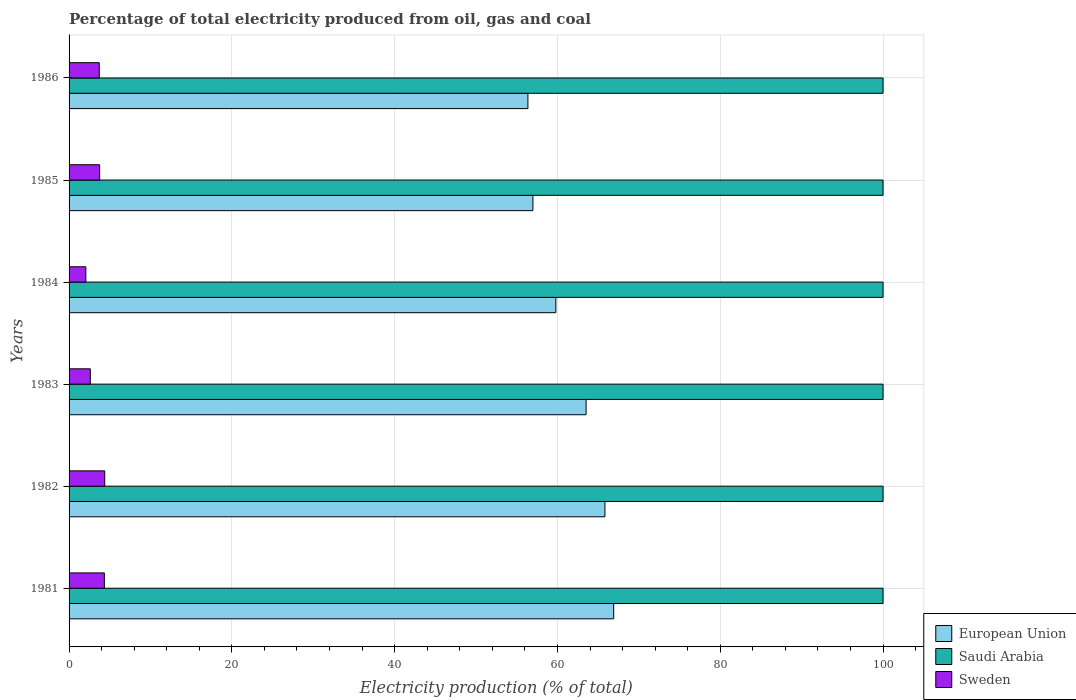How many groups of bars are there?
Provide a succinct answer. 6. Are the number of bars on each tick of the Y-axis equal?
Your answer should be compact. Yes. How many bars are there on the 4th tick from the bottom?
Give a very brief answer. 3. What is the label of the 5th group of bars from the top?
Give a very brief answer. 1982. In how many cases, is the number of bars for a given year not equal to the number of legend labels?
Your answer should be compact. 0. What is the electricity production in in Saudi Arabia in 1986?
Offer a very short reply. 100. Across all years, what is the maximum electricity production in in Saudi Arabia?
Offer a very short reply. 100. What is the total electricity production in in European Union in the graph?
Offer a terse response. 369.41. What is the difference between the electricity production in in Sweden in 1985 and that in 1986?
Ensure brevity in your answer.  0.05. What is the difference between the electricity production in in Sweden in 1982 and the electricity production in in Saudi Arabia in 1984?
Make the answer very short. -95.62. What is the average electricity production in in Sweden per year?
Your response must be concise. 3.48. In the year 1982, what is the difference between the electricity production in in Sweden and electricity production in in European Union?
Your answer should be very brief. -61.45. In how many years, is the electricity production in in Saudi Arabia greater than 40 %?
Your answer should be very brief. 6. What is the ratio of the electricity production in in European Union in 1982 to that in 1984?
Offer a very short reply. 1.1. Is the electricity production in in European Union in 1981 less than that in 1984?
Make the answer very short. No. Is the difference between the electricity production in in Sweden in 1981 and 1986 greater than the difference between the electricity production in in European Union in 1981 and 1986?
Your answer should be compact. No. What is the difference between the highest and the second highest electricity production in in Sweden?
Your response must be concise. 0.04. What is the difference between the highest and the lowest electricity production in in Sweden?
Keep it short and to the point. 2.32. In how many years, is the electricity production in in Saudi Arabia greater than the average electricity production in in Saudi Arabia taken over all years?
Provide a succinct answer. 0. What does the 3rd bar from the bottom in 1986 represents?
Ensure brevity in your answer.  Sweden. Is it the case that in every year, the sum of the electricity production in in Sweden and electricity production in in European Union is greater than the electricity production in in Saudi Arabia?
Offer a terse response. No. How many bars are there?
Your response must be concise. 18. Does the graph contain any zero values?
Make the answer very short. No. Where does the legend appear in the graph?
Keep it short and to the point. Bottom right. What is the title of the graph?
Offer a very short reply. Percentage of total electricity produced from oil, gas and coal. Does "Togo" appear as one of the legend labels in the graph?
Keep it short and to the point. No. What is the label or title of the X-axis?
Your response must be concise. Electricity production (% of total). What is the label or title of the Y-axis?
Make the answer very short. Years. What is the Electricity production (% of total) in European Union in 1981?
Provide a short and direct response. 66.91. What is the Electricity production (% of total) of Sweden in 1981?
Your answer should be compact. 4.34. What is the Electricity production (% of total) of European Union in 1982?
Ensure brevity in your answer.  65.83. What is the Electricity production (% of total) of Sweden in 1982?
Provide a short and direct response. 4.38. What is the Electricity production (% of total) of European Union in 1983?
Keep it short and to the point. 63.52. What is the Electricity production (% of total) in Saudi Arabia in 1983?
Offer a terse response. 100. What is the Electricity production (% of total) in Sweden in 1983?
Ensure brevity in your answer.  2.61. What is the Electricity production (% of total) of European Union in 1984?
Your answer should be very brief. 59.8. What is the Electricity production (% of total) in Saudi Arabia in 1984?
Your answer should be very brief. 100. What is the Electricity production (% of total) of Sweden in 1984?
Make the answer very short. 2.06. What is the Electricity production (% of total) of European Union in 1985?
Give a very brief answer. 56.98. What is the Electricity production (% of total) of Saudi Arabia in 1985?
Your answer should be very brief. 100. What is the Electricity production (% of total) in Sweden in 1985?
Make the answer very short. 3.76. What is the Electricity production (% of total) of European Union in 1986?
Ensure brevity in your answer.  56.37. What is the Electricity production (% of total) in Sweden in 1986?
Make the answer very short. 3.71. Across all years, what is the maximum Electricity production (% of total) in European Union?
Offer a very short reply. 66.91. Across all years, what is the maximum Electricity production (% of total) of Saudi Arabia?
Ensure brevity in your answer.  100. Across all years, what is the maximum Electricity production (% of total) of Sweden?
Your response must be concise. 4.38. Across all years, what is the minimum Electricity production (% of total) of European Union?
Keep it short and to the point. 56.37. Across all years, what is the minimum Electricity production (% of total) of Sweden?
Keep it short and to the point. 2.06. What is the total Electricity production (% of total) in European Union in the graph?
Your answer should be very brief. 369.41. What is the total Electricity production (% of total) of Saudi Arabia in the graph?
Your answer should be very brief. 600. What is the total Electricity production (% of total) of Sweden in the graph?
Offer a very short reply. 20.85. What is the difference between the Electricity production (% of total) of European Union in 1981 and that in 1982?
Make the answer very short. 1.08. What is the difference between the Electricity production (% of total) in Sweden in 1981 and that in 1982?
Make the answer very short. -0.04. What is the difference between the Electricity production (% of total) in European Union in 1981 and that in 1983?
Ensure brevity in your answer.  3.39. What is the difference between the Electricity production (% of total) in Sweden in 1981 and that in 1983?
Offer a terse response. 1.73. What is the difference between the Electricity production (% of total) in European Union in 1981 and that in 1984?
Make the answer very short. 7.11. What is the difference between the Electricity production (% of total) in Sweden in 1981 and that in 1984?
Offer a very short reply. 2.28. What is the difference between the Electricity production (% of total) in European Union in 1981 and that in 1985?
Offer a terse response. 9.92. What is the difference between the Electricity production (% of total) of Saudi Arabia in 1981 and that in 1985?
Your answer should be very brief. 0. What is the difference between the Electricity production (% of total) in Sweden in 1981 and that in 1985?
Make the answer very short. 0.58. What is the difference between the Electricity production (% of total) of European Union in 1981 and that in 1986?
Ensure brevity in your answer.  10.54. What is the difference between the Electricity production (% of total) of Sweden in 1981 and that in 1986?
Provide a short and direct response. 0.63. What is the difference between the Electricity production (% of total) of European Union in 1982 and that in 1983?
Your response must be concise. 2.32. What is the difference between the Electricity production (% of total) of Saudi Arabia in 1982 and that in 1983?
Make the answer very short. 0. What is the difference between the Electricity production (% of total) of Sweden in 1982 and that in 1983?
Provide a succinct answer. 1.77. What is the difference between the Electricity production (% of total) in European Union in 1982 and that in 1984?
Your response must be concise. 6.03. What is the difference between the Electricity production (% of total) of Saudi Arabia in 1982 and that in 1984?
Your answer should be compact. 0. What is the difference between the Electricity production (% of total) of Sweden in 1982 and that in 1984?
Provide a succinct answer. 2.32. What is the difference between the Electricity production (% of total) in European Union in 1982 and that in 1985?
Your answer should be very brief. 8.85. What is the difference between the Electricity production (% of total) in Saudi Arabia in 1982 and that in 1985?
Provide a succinct answer. 0. What is the difference between the Electricity production (% of total) of Sweden in 1982 and that in 1985?
Make the answer very short. 0.62. What is the difference between the Electricity production (% of total) of European Union in 1982 and that in 1986?
Make the answer very short. 9.46. What is the difference between the Electricity production (% of total) in Sweden in 1982 and that in 1986?
Offer a very short reply. 0.67. What is the difference between the Electricity production (% of total) of European Union in 1983 and that in 1984?
Provide a short and direct response. 3.72. What is the difference between the Electricity production (% of total) of Sweden in 1983 and that in 1984?
Provide a short and direct response. 0.55. What is the difference between the Electricity production (% of total) in European Union in 1983 and that in 1985?
Your response must be concise. 6.53. What is the difference between the Electricity production (% of total) of Saudi Arabia in 1983 and that in 1985?
Your answer should be very brief. 0. What is the difference between the Electricity production (% of total) of Sweden in 1983 and that in 1985?
Keep it short and to the point. -1.15. What is the difference between the Electricity production (% of total) in European Union in 1983 and that in 1986?
Ensure brevity in your answer.  7.14. What is the difference between the Electricity production (% of total) in Saudi Arabia in 1983 and that in 1986?
Offer a very short reply. 0. What is the difference between the Electricity production (% of total) of Sweden in 1983 and that in 1986?
Ensure brevity in your answer.  -1.1. What is the difference between the Electricity production (% of total) of European Union in 1984 and that in 1985?
Provide a short and direct response. 2.82. What is the difference between the Electricity production (% of total) of Sweden in 1984 and that in 1985?
Make the answer very short. -1.7. What is the difference between the Electricity production (% of total) of European Union in 1984 and that in 1986?
Your response must be concise. 3.43. What is the difference between the Electricity production (% of total) in Sweden in 1984 and that in 1986?
Ensure brevity in your answer.  -1.65. What is the difference between the Electricity production (% of total) in European Union in 1985 and that in 1986?
Provide a succinct answer. 0.61. What is the difference between the Electricity production (% of total) of Sweden in 1985 and that in 1986?
Ensure brevity in your answer.  0.05. What is the difference between the Electricity production (% of total) of European Union in 1981 and the Electricity production (% of total) of Saudi Arabia in 1982?
Keep it short and to the point. -33.09. What is the difference between the Electricity production (% of total) in European Union in 1981 and the Electricity production (% of total) in Sweden in 1982?
Provide a succinct answer. 62.53. What is the difference between the Electricity production (% of total) of Saudi Arabia in 1981 and the Electricity production (% of total) of Sweden in 1982?
Ensure brevity in your answer.  95.62. What is the difference between the Electricity production (% of total) of European Union in 1981 and the Electricity production (% of total) of Saudi Arabia in 1983?
Ensure brevity in your answer.  -33.09. What is the difference between the Electricity production (% of total) of European Union in 1981 and the Electricity production (% of total) of Sweden in 1983?
Offer a terse response. 64.3. What is the difference between the Electricity production (% of total) of Saudi Arabia in 1981 and the Electricity production (% of total) of Sweden in 1983?
Your response must be concise. 97.39. What is the difference between the Electricity production (% of total) of European Union in 1981 and the Electricity production (% of total) of Saudi Arabia in 1984?
Offer a terse response. -33.09. What is the difference between the Electricity production (% of total) in European Union in 1981 and the Electricity production (% of total) in Sweden in 1984?
Provide a succinct answer. 64.85. What is the difference between the Electricity production (% of total) in Saudi Arabia in 1981 and the Electricity production (% of total) in Sweden in 1984?
Offer a terse response. 97.94. What is the difference between the Electricity production (% of total) in European Union in 1981 and the Electricity production (% of total) in Saudi Arabia in 1985?
Make the answer very short. -33.09. What is the difference between the Electricity production (% of total) in European Union in 1981 and the Electricity production (% of total) in Sweden in 1985?
Ensure brevity in your answer.  63.15. What is the difference between the Electricity production (% of total) of Saudi Arabia in 1981 and the Electricity production (% of total) of Sweden in 1985?
Provide a short and direct response. 96.24. What is the difference between the Electricity production (% of total) of European Union in 1981 and the Electricity production (% of total) of Saudi Arabia in 1986?
Ensure brevity in your answer.  -33.09. What is the difference between the Electricity production (% of total) in European Union in 1981 and the Electricity production (% of total) in Sweden in 1986?
Your answer should be very brief. 63.2. What is the difference between the Electricity production (% of total) in Saudi Arabia in 1981 and the Electricity production (% of total) in Sweden in 1986?
Make the answer very short. 96.29. What is the difference between the Electricity production (% of total) in European Union in 1982 and the Electricity production (% of total) in Saudi Arabia in 1983?
Provide a succinct answer. -34.17. What is the difference between the Electricity production (% of total) of European Union in 1982 and the Electricity production (% of total) of Sweden in 1983?
Provide a short and direct response. 63.22. What is the difference between the Electricity production (% of total) of Saudi Arabia in 1982 and the Electricity production (% of total) of Sweden in 1983?
Ensure brevity in your answer.  97.39. What is the difference between the Electricity production (% of total) in European Union in 1982 and the Electricity production (% of total) in Saudi Arabia in 1984?
Keep it short and to the point. -34.17. What is the difference between the Electricity production (% of total) of European Union in 1982 and the Electricity production (% of total) of Sweden in 1984?
Provide a succinct answer. 63.77. What is the difference between the Electricity production (% of total) of Saudi Arabia in 1982 and the Electricity production (% of total) of Sweden in 1984?
Ensure brevity in your answer.  97.94. What is the difference between the Electricity production (% of total) of European Union in 1982 and the Electricity production (% of total) of Saudi Arabia in 1985?
Ensure brevity in your answer.  -34.17. What is the difference between the Electricity production (% of total) of European Union in 1982 and the Electricity production (% of total) of Sweden in 1985?
Provide a succinct answer. 62.07. What is the difference between the Electricity production (% of total) of Saudi Arabia in 1982 and the Electricity production (% of total) of Sweden in 1985?
Keep it short and to the point. 96.24. What is the difference between the Electricity production (% of total) in European Union in 1982 and the Electricity production (% of total) in Saudi Arabia in 1986?
Your answer should be very brief. -34.17. What is the difference between the Electricity production (% of total) in European Union in 1982 and the Electricity production (% of total) in Sweden in 1986?
Your response must be concise. 62.12. What is the difference between the Electricity production (% of total) of Saudi Arabia in 1982 and the Electricity production (% of total) of Sweden in 1986?
Offer a very short reply. 96.29. What is the difference between the Electricity production (% of total) of European Union in 1983 and the Electricity production (% of total) of Saudi Arabia in 1984?
Make the answer very short. -36.48. What is the difference between the Electricity production (% of total) in European Union in 1983 and the Electricity production (% of total) in Sweden in 1984?
Provide a short and direct response. 61.46. What is the difference between the Electricity production (% of total) of Saudi Arabia in 1983 and the Electricity production (% of total) of Sweden in 1984?
Your answer should be very brief. 97.94. What is the difference between the Electricity production (% of total) in European Union in 1983 and the Electricity production (% of total) in Saudi Arabia in 1985?
Make the answer very short. -36.48. What is the difference between the Electricity production (% of total) of European Union in 1983 and the Electricity production (% of total) of Sweden in 1985?
Your response must be concise. 59.76. What is the difference between the Electricity production (% of total) in Saudi Arabia in 1983 and the Electricity production (% of total) in Sweden in 1985?
Your answer should be compact. 96.24. What is the difference between the Electricity production (% of total) in European Union in 1983 and the Electricity production (% of total) in Saudi Arabia in 1986?
Make the answer very short. -36.48. What is the difference between the Electricity production (% of total) of European Union in 1983 and the Electricity production (% of total) of Sweden in 1986?
Your response must be concise. 59.81. What is the difference between the Electricity production (% of total) of Saudi Arabia in 1983 and the Electricity production (% of total) of Sweden in 1986?
Your response must be concise. 96.29. What is the difference between the Electricity production (% of total) in European Union in 1984 and the Electricity production (% of total) in Saudi Arabia in 1985?
Provide a succinct answer. -40.2. What is the difference between the Electricity production (% of total) in European Union in 1984 and the Electricity production (% of total) in Sweden in 1985?
Your response must be concise. 56.04. What is the difference between the Electricity production (% of total) of Saudi Arabia in 1984 and the Electricity production (% of total) of Sweden in 1985?
Offer a terse response. 96.24. What is the difference between the Electricity production (% of total) in European Union in 1984 and the Electricity production (% of total) in Saudi Arabia in 1986?
Provide a succinct answer. -40.2. What is the difference between the Electricity production (% of total) in European Union in 1984 and the Electricity production (% of total) in Sweden in 1986?
Keep it short and to the point. 56.09. What is the difference between the Electricity production (% of total) of Saudi Arabia in 1984 and the Electricity production (% of total) of Sweden in 1986?
Offer a terse response. 96.29. What is the difference between the Electricity production (% of total) of European Union in 1985 and the Electricity production (% of total) of Saudi Arabia in 1986?
Ensure brevity in your answer.  -43.02. What is the difference between the Electricity production (% of total) of European Union in 1985 and the Electricity production (% of total) of Sweden in 1986?
Offer a terse response. 53.28. What is the difference between the Electricity production (% of total) in Saudi Arabia in 1985 and the Electricity production (% of total) in Sweden in 1986?
Offer a terse response. 96.29. What is the average Electricity production (% of total) in European Union per year?
Provide a short and direct response. 61.57. What is the average Electricity production (% of total) in Saudi Arabia per year?
Offer a very short reply. 100. What is the average Electricity production (% of total) in Sweden per year?
Ensure brevity in your answer.  3.48. In the year 1981, what is the difference between the Electricity production (% of total) in European Union and Electricity production (% of total) in Saudi Arabia?
Your answer should be very brief. -33.09. In the year 1981, what is the difference between the Electricity production (% of total) in European Union and Electricity production (% of total) in Sweden?
Your answer should be very brief. 62.57. In the year 1981, what is the difference between the Electricity production (% of total) in Saudi Arabia and Electricity production (% of total) in Sweden?
Your answer should be very brief. 95.66. In the year 1982, what is the difference between the Electricity production (% of total) of European Union and Electricity production (% of total) of Saudi Arabia?
Your response must be concise. -34.17. In the year 1982, what is the difference between the Electricity production (% of total) in European Union and Electricity production (% of total) in Sweden?
Offer a terse response. 61.45. In the year 1982, what is the difference between the Electricity production (% of total) in Saudi Arabia and Electricity production (% of total) in Sweden?
Make the answer very short. 95.62. In the year 1983, what is the difference between the Electricity production (% of total) of European Union and Electricity production (% of total) of Saudi Arabia?
Your response must be concise. -36.48. In the year 1983, what is the difference between the Electricity production (% of total) in European Union and Electricity production (% of total) in Sweden?
Keep it short and to the point. 60.91. In the year 1983, what is the difference between the Electricity production (% of total) in Saudi Arabia and Electricity production (% of total) in Sweden?
Your answer should be very brief. 97.39. In the year 1984, what is the difference between the Electricity production (% of total) in European Union and Electricity production (% of total) in Saudi Arabia?
Ensure brevity in your answer.  -40.2. In the year 1984, what is the difference between the Electricity production (% of total) in European Union and Electricity production (% of total) in Sweden?
Offer a terse response. 57.74. In the year 1984, what is the difference between the Electricity production (% of total) of Saudi Arabia and Electricity production (% of total) of Sweden?
Ensure brevity in your answer.  97.94. In the year 1985, what is the difference between the Electricity production (% of total) of European Union and Electricity production (% of total) of Saudi Arabia?
Provide a short and direct response. -43.02. In the year 1985, what is the difference between the Electricity production (% of total) in European Union and Electricity production (% of total) in Sweden?
Provide a succinct answer. 53.23. In the year 1985, what is the difference between the Electricity production (% of total) in Saudi Arabia and Electricity production (% of total) in Sweden?
Your answer should be very brief. 96.24. In the year 1986, what is the difference between the Electricity production (% of total) of European Union and Electricity production (% of total) of Saudi Arabia?
Your response must be concise. -43.63. In the year 1986, what is the difference between the Electricity production (% of total) in European Union and Electricity production (% of total) in Sweden?
Ensure brevity in your answer.  52.66. In the year 1986, what is the difference between the Electricity production (% of total) in Saudi Arabia and Electricity production (% of total) in Sweden?
Your response must be concise. 96.29. What is the ratio of the Electricity production (% of total) of European Union in 1981 to that in 1982?
Your answer should be compact. 1.02. What is the ratio of the Electricity production (% of total) in Saudi Arabia in 1981 to that in 1982?
Your response must be concise. 1. What is the ratio of the Electricity production (% of total) of Sweden in 1981 to that in 1982?
Your answer should be compact. 0.99. What is the ratio of the Electricity production (% of total) of European Union in 1981 to that in 1983?
Make the answer very short. 1.05. What is the ratio of the Electricity production (% of total) of Sweden in 1981 to that in 1983?
Your response must be concise. 1.66. What is the ratio of the Electricity production (% of total) in European Union in 1981 to that in 1984?
Offer a very short reply. 1.12. What is the ratio of the Electricity production (% of total) in Sweden in 1981 to that in 1984?
Make the answer very short. 2.1. What is the ratio of the Electricity production (% of total) in European Union in 1981 to that in 1985?
Provide a succinct answer. 1.17. What is the ratio of the Electricity production (% of total) in Saudi Arabia in 1981 to that in 1985?
Your answer should be compact. 1. What is the ratio of the Electricity production (% of total) of Sweden in 1981 to that in 1985?
Offer a terse response. 1.15. What is the ratio of the Electricity production (% of total) of European Union in 1981 to that in 1986?
Offer a terse response. 1.19. What is the ratio of the Electricity production (% of total) in Saudi Arabia in 1981 to that in 1986?
Give a very brief answer. 1. What is the ratio of the Electricity production (% of total) of Sweden in 1981 to that in 1986?
Offer a terse response. 1.17. What is the ratio of the Electricity production (% of total) of European Union in 1982 to that in 1983?
Ensure brevity in your answer.  1.04. What is the ratio of the Electricity production (% of total) in Sweden in 1982 to that in 1983?
Ensure brevity in your answer.  1.68. What is the ratio of the Electricity production (% of total) of European Union in 1982 to that in 1984?
Provide a short and direct response. 1.1. What is the ratio of the Electricity production (% of total) in Saudi Arabia in 1982 to that in 1984?
Give a very brief answer. 1. What is the ratio of the Electricity production (% of total) in Sweden in 1982 to that in 1984?
Give a very brief answer. 2.13. What is the ratio of the Electricity production (% of total) of European Union in 1982 to that in 1985?
Offer a terse response. 1.16. What is the ratio of the Electricity production (% of total) of Saudi Arabia in 1982 to that in 1985?
Make the answer very short. 1. What is the ratio of the Electricity production (% of total) in Sweden in 1982 to that in 1985?
Offer a very short reply. 1.17. What is the ratio of the Electricity production (% of total) in European Union in 1982 to that in 1986?
Give a very brief answer. 1.17. What is the ratio of the Electricity production (% of total) of Saudi Arabia in 1982 to that in 1986?
Provide a short and direct response. 1. What is the ratio of the Electricity production (% of total) in Sweden in 1982 to that in 1986?
Make the answer very short. 1.18. What is the ratio of the Electricity production (% of total) of European Union in 1983 to that in 1984?
Provide a short and direct response. 1.06. What is the ratio of the Electricity production (% of total) in Saudi Arabia in 1983 to that in 1984?
Ensure brevity in your answer.  1. What is the ratio of the Electricity production (% of total) in Sweden in 1983 to that in 1984?
Offer a very short reply. 1.27. What is the ratio of the Electricity production (% of total) in European Union in 1983 to that in 1985?
Make the answer very short. 1.11. What is the ratio of the Electricity production (% of total) in Saudi Arabia in 1983 to that in 1985?
Provide a succinct answer. 1. What is the ratio of the Electricity production (% of total) of Sweden in 1983 to that in 1985?
Offer a very short reply. 0.69. What is the ratio of the Electricity production (% of total) in European Union in 1983 to that in 1986?
Ensure brevity in your answer.  1.13. What is the ratio of the Electricity production (% of total) of Sweden in 1983 to that in 1986?
Your answer should be very brief. 0.7. What is the ratio of the Electricity production (% of total) in European Union in 1984 to that in 1985?
Make the answer very short. 1.05. What is the ratio of the Electricity production (% of total) of Saudi Arabia in 1984 to that in 1985?
Provide a succinct answer. 1. What is the ratio of the Electricity production (% of total) of Sweden in 1984 to that in 1985?
Provide a succinct answer. 0.55. What is the ratio of the Electricity production (% of total) of European Union in 1984 to that in 1986?
Your answer should be compact. 1.06. What is the ratio of the Electricity production (% of total) in Saudi Arabia in 1984 to that in 1986?
Make the answer very short. 1. What is the ratio of the Electricity production (% of total) in Sweden in 1984 to that in 1986?
Your answer should be very brief. 0.56. What is the ratio of the Electricity production (% of total) of European Union in 1985 to that in 1986?
Provide a short and direct response. 1.01. What is the ratio of the Electricity production (% of total) in Saudi Arabia in 1985 to that in 1986?
Give a very brief answer. 1. What is the ratio of the Electricity production (% of total) of Sweden in 1985 to that in 1986?
Your response must be concise. 1.01. What is the difference between the highest and the second highest Electricity production (% of total) of European Union?
Provide a succinct answer. 1.08. What is the difference between the highest and the second highest Electricity production (% of total) in Saudi Arabia?
Ensure brevity in your answer.  0. What is the difference between the highest and the second highest Electricity production (% of total) in Sweden?
Ensure brevity in your answer.  0.04. What is the difference between the highest and the lowest Electricity production (% of total) in European Union?
Give a very brief answer. 10.54. What is the difference between the highest and the lowest Electricity production (% of total) in Saudi Arabia?
Make the answer very short. 0. What is the difference between the highest and the lowest Electricity production (% of total) in Sweden?
Your answer should be very brief. 2.32. 